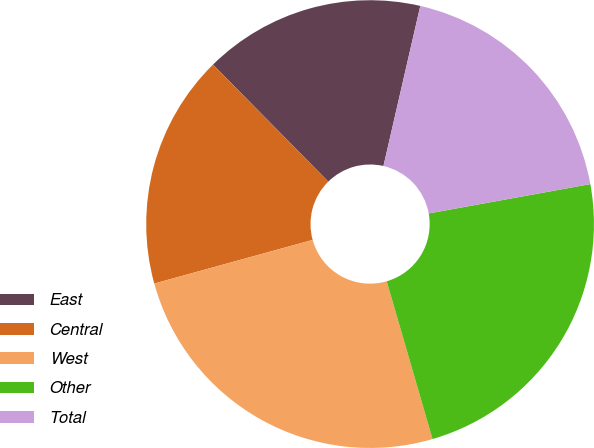Convert chart to OTSL. <chart><loc_0><loc_0><loc_500><loc_500><pie_chart><fcel>East<fcel>Central<fcel>West<fcel>Other<fcel>Total<nl><fcel>15.98%<fcel>16.9%<fcel>25.22%<fcel>23.36%<fcel>18.54%<nl></chart> 